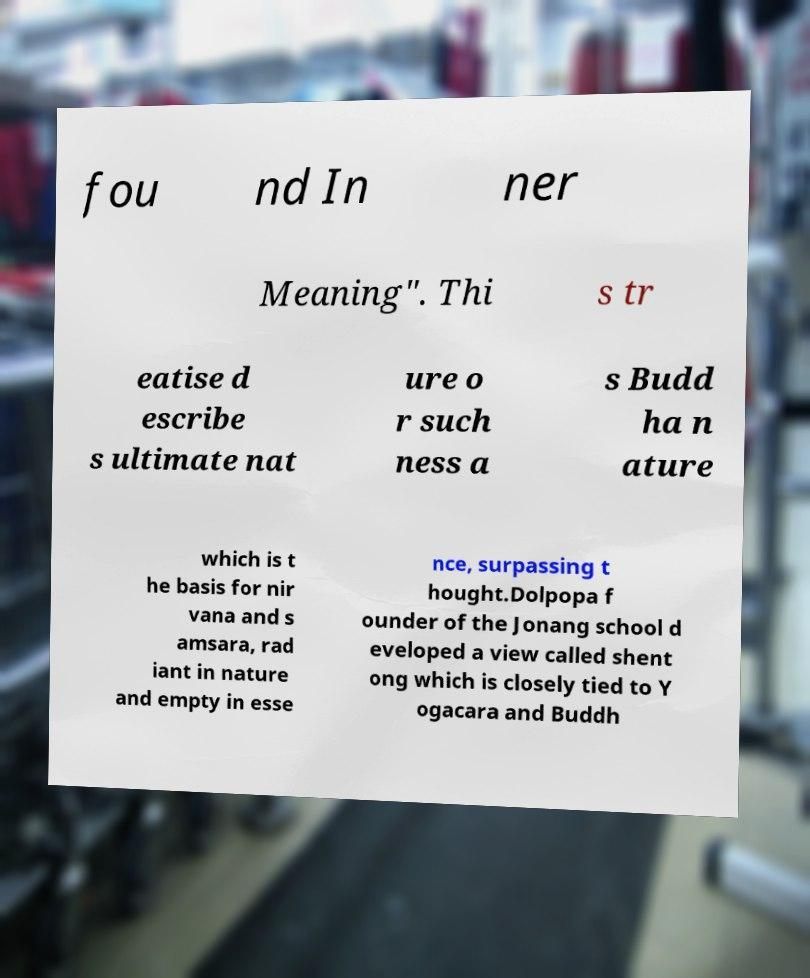I need the written content from this picture converted into text. Can you do that? fou nd In ner Meaning". Thi s tr eatise d escribe s ultimate nat ure o r such ness a s Budd ha n ature which is t he basis for nir vana and s amsara, rad iant in nature and empty in esse nce, surpassing t hought.Dolpopa f ounder of the Jonang school d eveloped a view called shent ong which is closely tied to Y ogacara and Buddh 